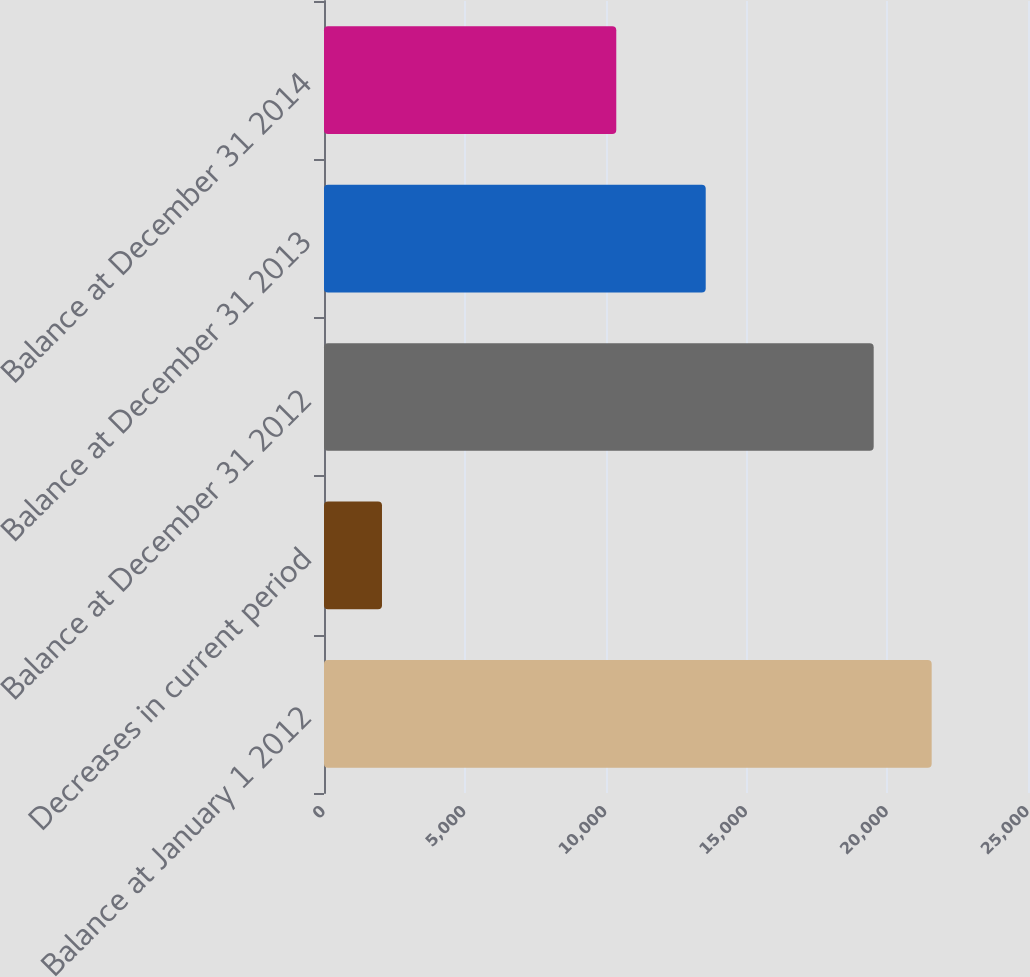Convert chart. <chart><loc_0><loc_0><loc_500><loc_500><bar_chart><fcel>Balance at January 1 2012<fcel>Decreases in current period<fcel>Balance at December 31 2012<fcel>Balance at December 31 2013<fcel>Balance at December 31 2014<nl><fcel>21579<fcel>2059<fcel>19520<fcel>13555<fcel>10379<nl></chart> 